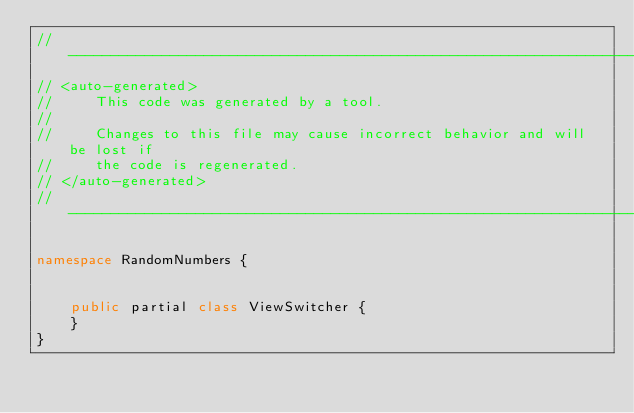<code> <loc_0><loc_0><loc_500><loc_500><_C#_>//------------------------------------------------------------------------------
// <auto-generated>
//     This code was generated by a tool.
//
//     Changes to this file may cause incorrect behavior and will be lost if
//     the code is regenerated. 
// </auto-generated>
//------------------------------------------------------------------------------

namespace RandomNumbers {
    
    
    public partial class ViewSwitcher {
    }
}
</code> 